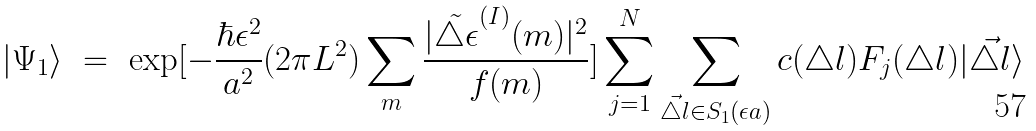Convert formula to latex. <formula><loc_0><loc_0><loc_500><loc_500>| \Psi _ { 1 } \rangle \ = \ \exp [ - \frac { \hbar { \epsilon } ^ { 2 } } { a ^ { 2 } } ( 2 \pi L ^ { 2 } ) \sum _ { m } \frac { | \tilde { \triangle \epsilon } ^ { ( I ) } ( m ) | ^ { 2 } } { f ( m ) } ] \sum _ { j = 1 } ^ { N } \sum _ { \vec { \triangle l } \in S _ { 1 } ( \epsilon a ) } c ( \triangle l ) F _ { j } ( \triangle l ) | \vec { \triangle l } \rangle</formula> 